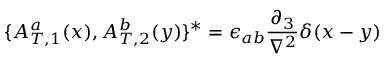<formula> <loc_0><loc_0><loc_500><loc_500>\{ { A _ { T , 1 } ^ { a } } ( x ) , { A _ { T , 2 } ^ { b } } ( y ) \} ^ { * } = \epsilon _ { a b } \frac { \partial _ { 3 } } { \nabla ^ { 2 } } \delta ( x - y )</formula> 